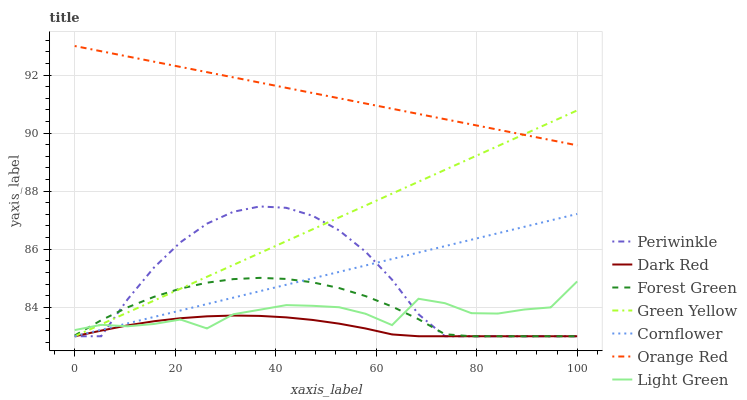Does Forest Green have the minimum area under the curve?
Answer yes or no. No. Does Forest Green have the maximum area under the curve?
Answer yes or no. No. Is Dark Red the smoothest?
Answer yes or no. No. Is Dark Red the roughest?
Answer yes or no. No. Does Light Green have the lowest value?
Answer yes or no. No. Does Forest Green have the highest value?
Answer yes or no. No. Is Periwinkle less than Orange Red?
Answer yes or no. Yes. Is Orange Red greater than Cornflower?
Answer yes or no. Yes. Does Periwinkle intersect Orange Red?
Answer yes or no. No. 